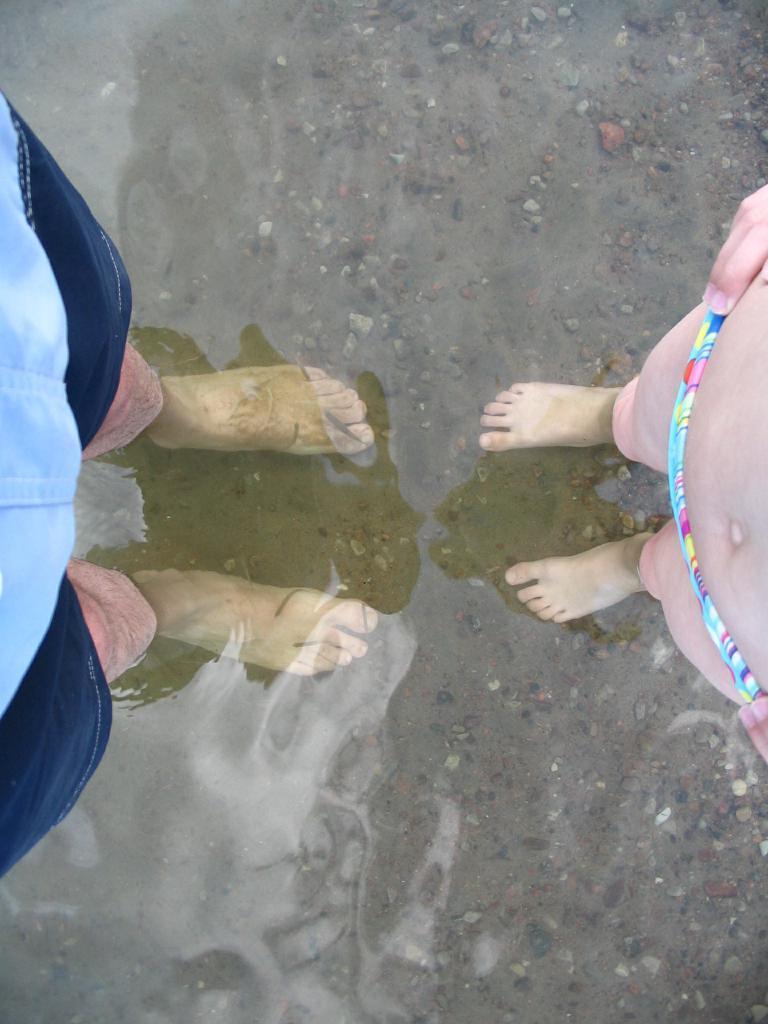Can you describe this image briefly? In the center of the image we can see two persons are standing in the water and they are in different costumes. In the background we can see water and sand. 